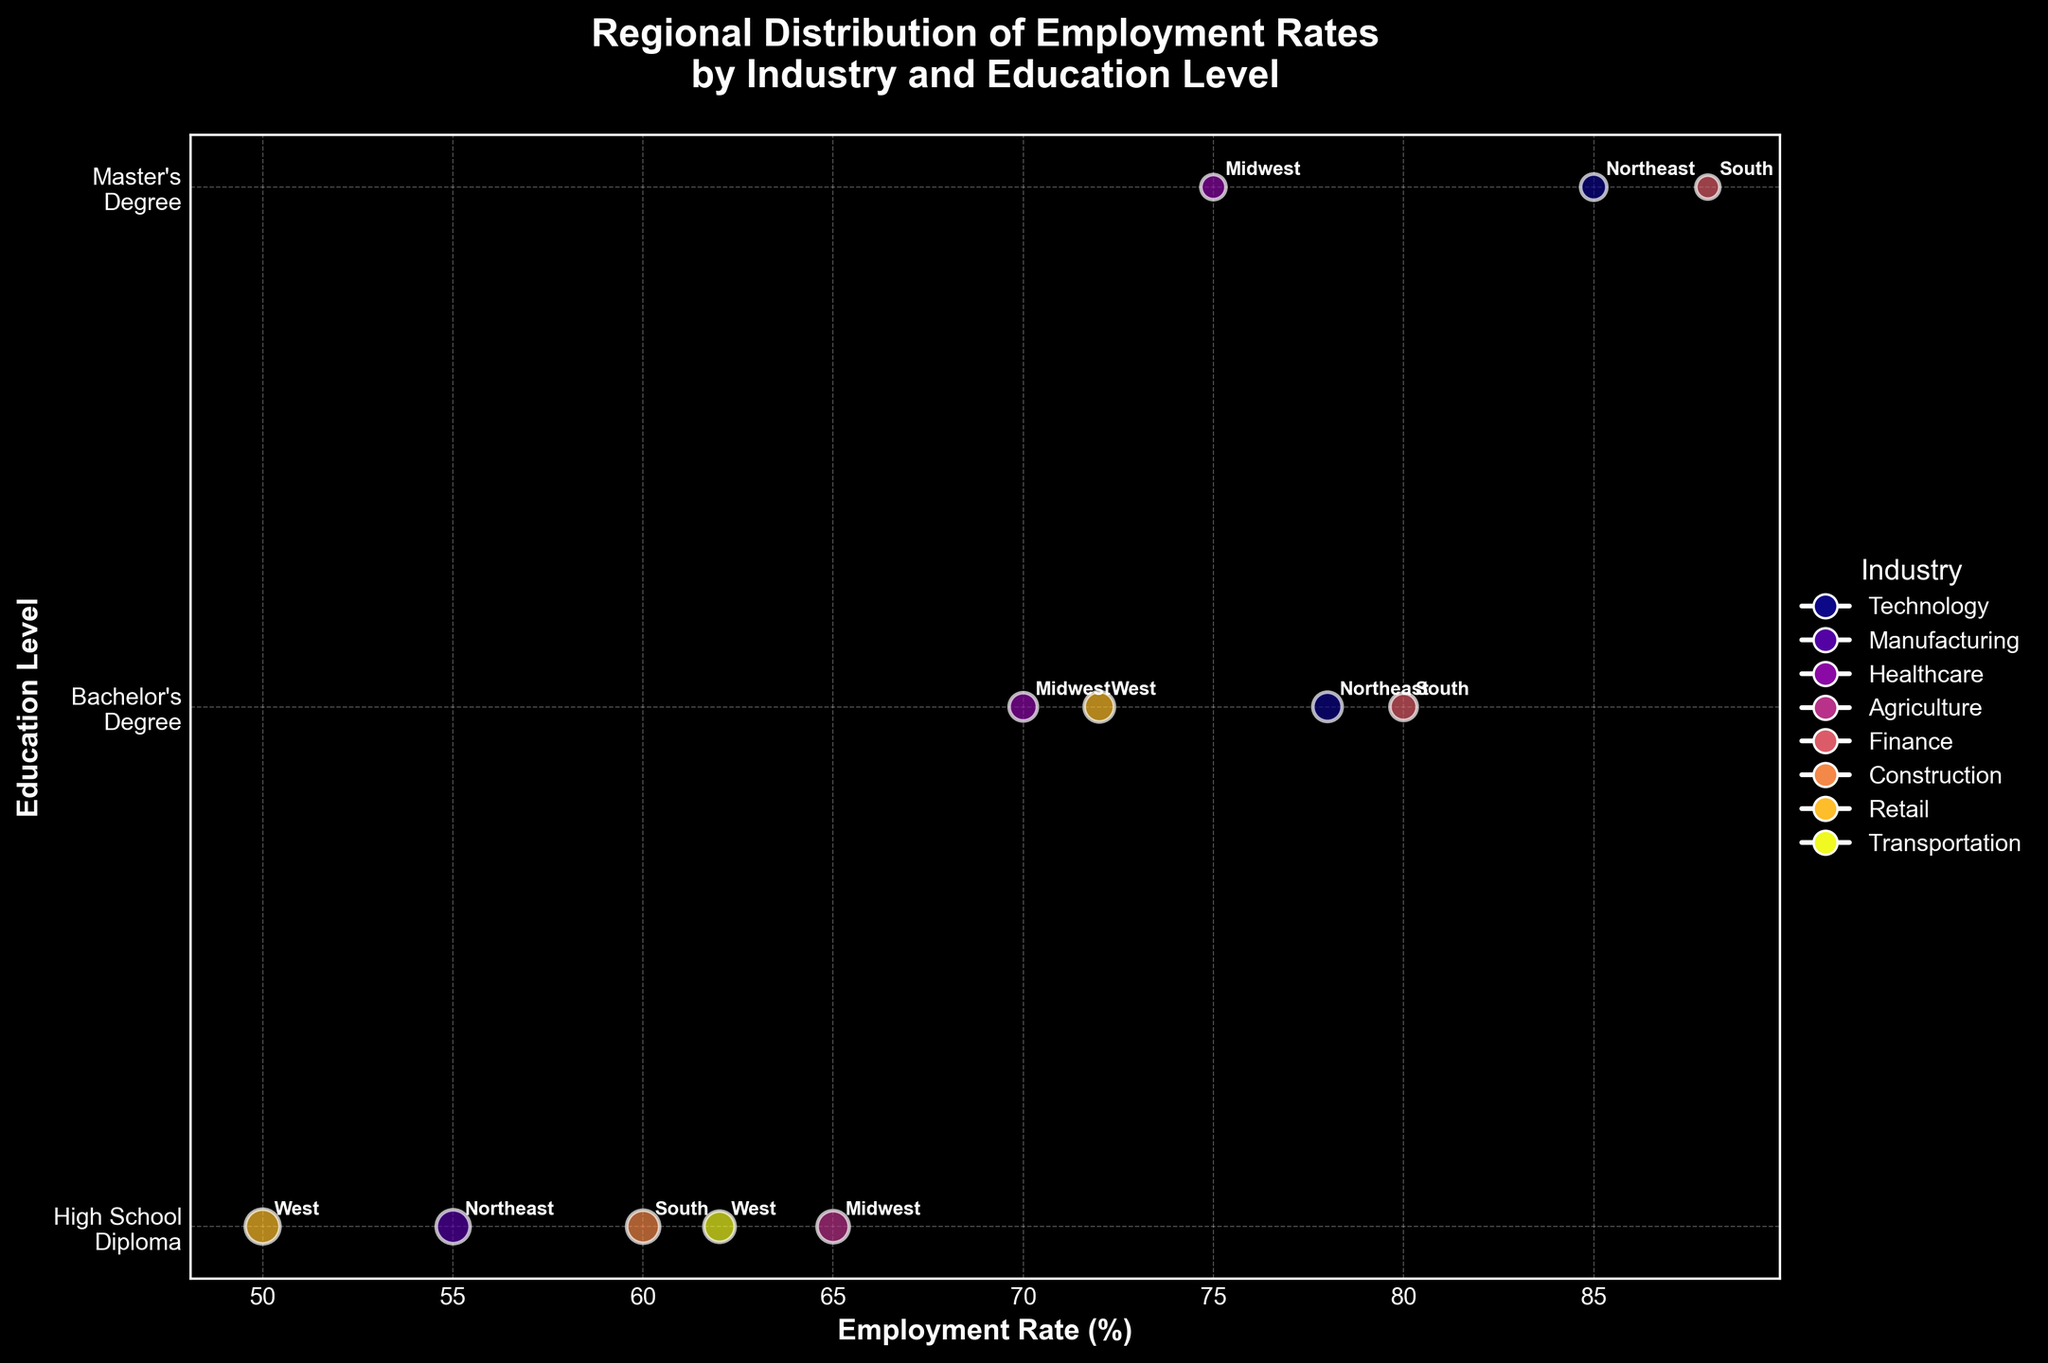What is the employment rate for the "Technology" industry with a "Master's Degree" education level in the Northeast region? Look at the plot where there are bubbles labeled Northeast and colored according to the Technology industry. Also, check that the y-axis position corresponds to "Master's Degree".
Answer: 85 Which industry has the largest bubble size within any region? The largest bubble size is indicated by the largest bubble area on the plot. Compare bubble areas across all industries.
Answer: Manufacturing in the Northeast In which region is the employment rate highest for the "Finance" industry with a "Master's Degree"? Identify the bubbles associated with the Finance industry and "Master's Degree" education level. Then, compare the employment rates for these bubbles across regions.
Answer: South What is the average employment rate for industries located in the West region? Identify all bubbles tagged with the West region. Sum their employment rates and divide by the number of bubbles. West region's employment rates: Retail (50, 72), Transportation (62). Average is (50 + 72 + 62)/3.
Answer: 61.33 How does the employment rate for the "Construction" industry with a "High School Diploma" in the South compare to the "Agriculture" industry with the same education level in the Midwest? Find and compare the employment rates of the specific industries with "High School Diploma" in the specified regions.
Answer: Construction in South is 60; Agriculture in Midwest is 65 Which education level shows the highest average employment rate across all industries in the Northeast region? Identify bubbles from the "Northeast" and group them by education level. Calculate the average employment rate for each group. Northeast region's employment rates: High School Diploma (55), Bachelor's Degree (78), Master's Degree (85). Average: High School Diploma = 55; Bachelor's Degree = 78; Master's Degree = 85. Highest is Master's Degree.
Answer: Master's Degree What is the employment rate difference between the "Retail" and "Transportation" industries in the West for individuals with a "High School Diploma"? Locate bubbles in the West region for "Retail" and "Transportation" with "High School Diploma." Subtract the employment rates.
Answer: 50 - 62 = -12 How many industries have an employment rate above 75 in the Midwest? Identify bubbles in the Midwest region and count those with an employment rate greater than 75.
Answer: 1 (Healthcare with Master's Degree) What industries within the South region have employment rates higher than 80, and what are their corresponding education levels? Locate bubbles in the South region with employment rates higher than 80. Note the industries and their education levels.
Answer: Finance (Bachelor's Degree, Master's Degree) How does the bubble size for "Healthcare" in the Midwest with a Master's Degree compare to that for "Finance" in the South with a Bachelor's Degree? Compare the visual sizes of the bubbles: "Healthcare" in Midwest with a Master's Degree and "Finance" in South with a Bachelor's Degree.
Answer: Healthcare (11000), Finance (13000); Finance is larger 